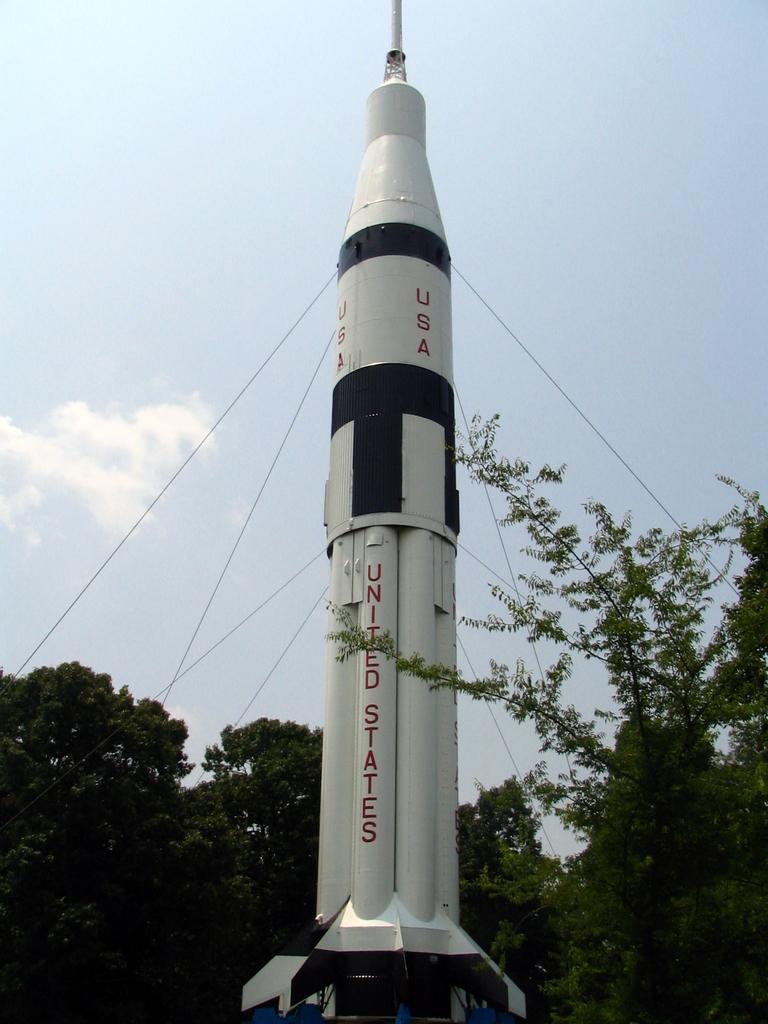How would you summarize this image in a sentence or two? In this image there is a rocket, trees and sky. Something is written on the rocket. 